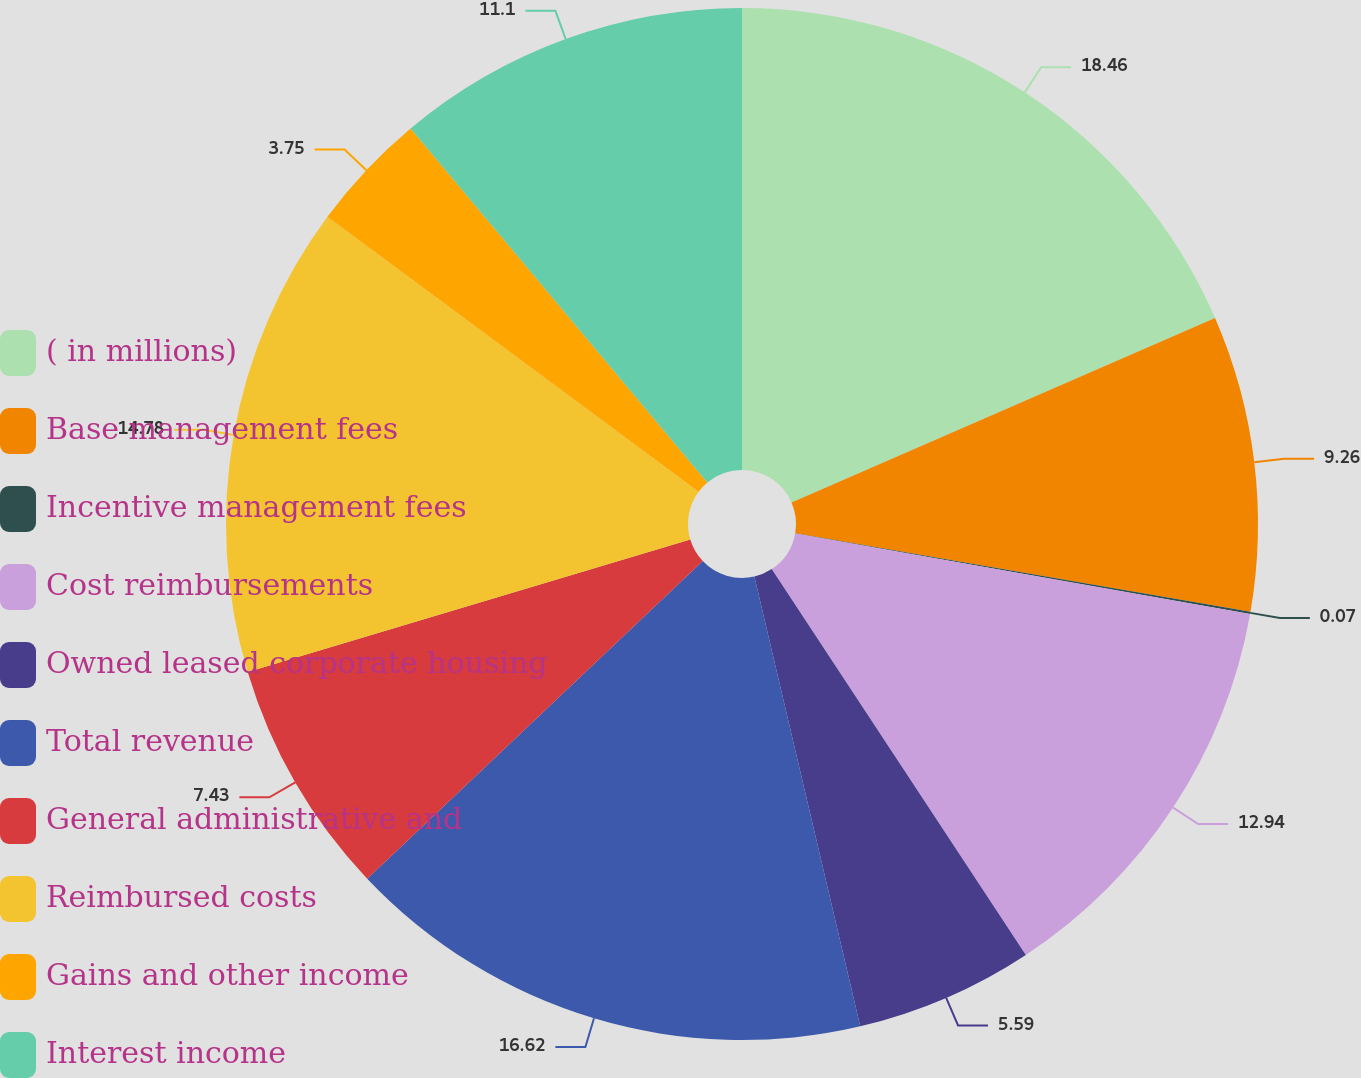<chart> <loc_0><loc_0><loc_500><loc_500><pie_chart><fcel>( in millions)<fcel>Base management fees<fcel>Incentive management fees<fcel>Cost reimbursements<fcel>Owned leased corporate housing<fcel>Total revenue<fcel>General administrative and<fcel>Reimbursed costs<fcel>Gains and other income<fcel>Interest income<nl><fcel>18.46%<fcel>9.26%<fcel>0.07%<fcel>12.94%<fcel>5.59%<fcel>16.62%<fcel>7.43%<fcel>14.78%<fcel>3.75%<fcel>11.1%<nl></chart> 